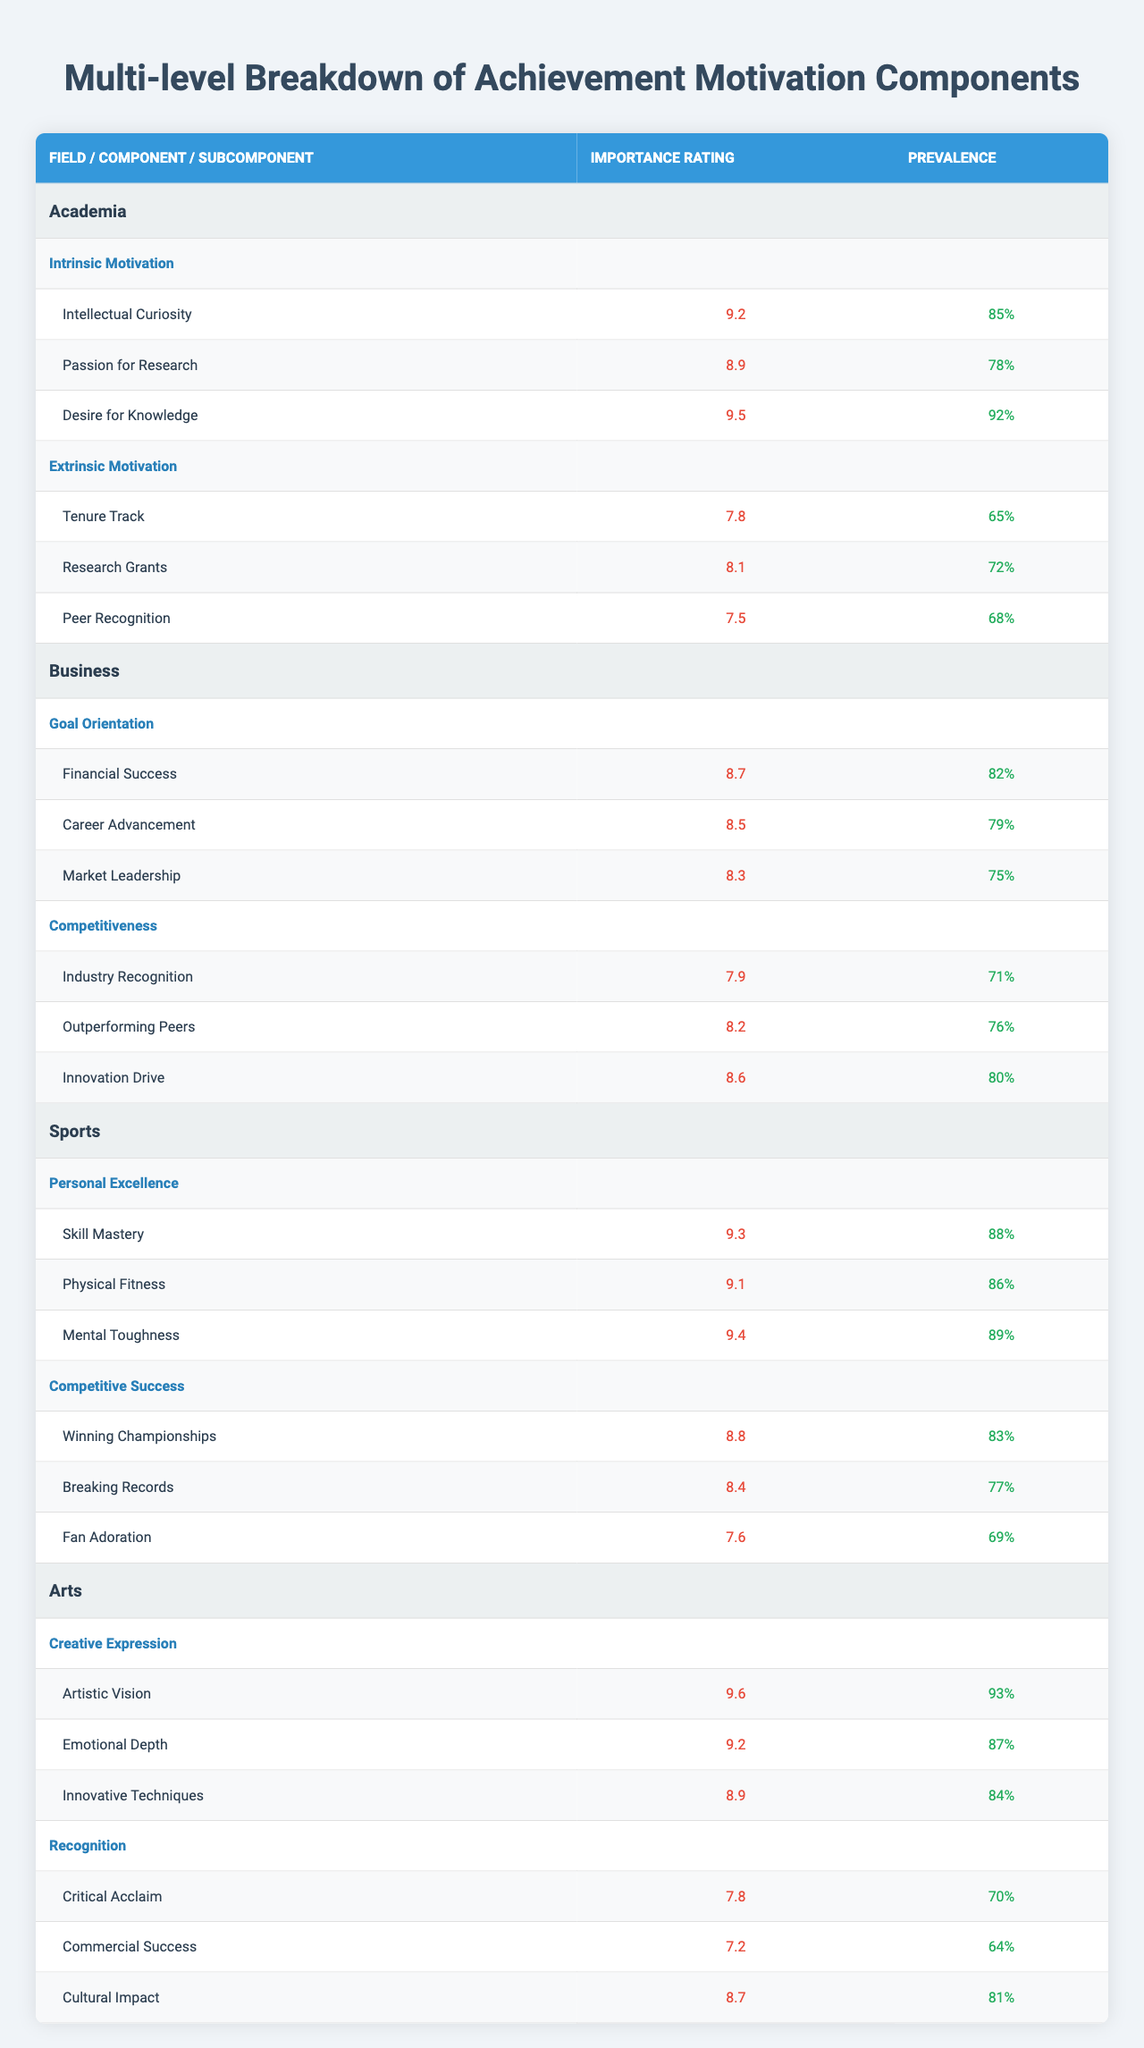What is the highest importance rating for a subcomponent in academia? The subcomponent with the highest importance rating in academia is "Desire for Knowledge," which has an importance rating of 9.5.
Answer: 9.5 Which professional field has the lowest subcomponent prevalence percentage? In the Arts field, the subcomponent with the lowest prevalence percentage is "Commercial Success," which is at 64%.
Answer: 64% What is the average importance rating of the subcomponents for the business field? For business, the importance ratings are 8.7, 8.5, and 8.3. Summing these gives 8.7 + 8.5 + 8.3 = 25.5, and dividing by 3 gives an average of 25.5 / 3 = 8.5.
Answer: 8.5 Is the prevalence of "Mental Toughness" higher than that of "Fan Adoration"? "Mental Toughness" has a prevalence of 89%, while "Fan Adoration" has a prevalence of 69%. Since 89% is greater than 69%, the statement is true.
Answer: Yes In which field do the components related to intrinsic motivation score highest? The field of academia has the highest importance ratings for intrinsic motivation components, particularly "Desire for Knowledge" with 9.5 and "Intrinsic Motivation" overall showing high ratings.
Answer: Academia What is the difference in importance ratings between "Financial Success" and "Industry Recognition"? The importance rating for "Financial Success" is 8.7 and for "Industry Recognition" it is 7.9. The difference is 8.7 - 7.9 = 0.8.
Answer: 0.8 Which subcomponent has the highest prevalence in the sports field, and what is that percentage? The subcomponent with the highest prevalence in the sports field is "Mental Toughness," with a prevalence of 89%.
Answer: 89% Are the importance ratings for all components in the Arts field above 8? The importance ratings for the Arts field subcomponents are 9.6, 9.2, 8.9, 7.8, 7.2, and 8.7. Since "Commercial Success" at 7.2 is below 8, the statement is false.
Answer: No What is the percentage prevalence of "Innovation Drive"? The prevalence of "Innovation Drive" is 80%.
Answer: 80% Which component in sports has subcomponents with the highest average importance rating? The "Personal Excellence" component has importance ratings of 9.3, 9.1, and 9.4. Summing these gives 9.3 + 9.1 + 9.4 = 27.8, and dividing by 3 gives an average of 27.8 / 3 = 9.27, which is the highest average.
Answer: Personal Excellence 